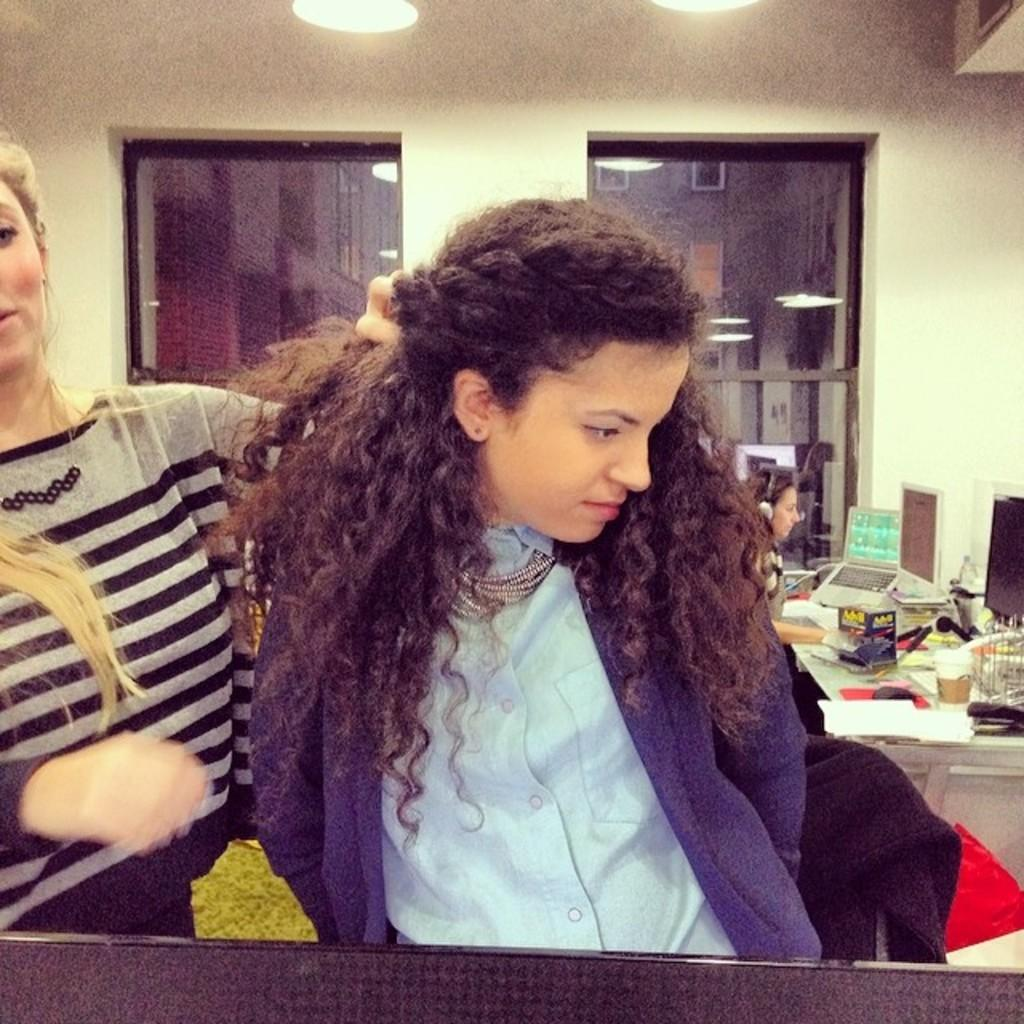Who or what can be seen in the image? There are people in the image. What is on the table in the image? There are monitors and other objects on the table. Can you describe the lighting in the image? There are lights visible in the image. What is the background of the image? There is a wall in the image. What type of waste is being recycled in the image? There is no waste or recycling depicted in the image. What level of comfort do the people in the image appear to have? The image does not provide information about the comfort level of the people. 